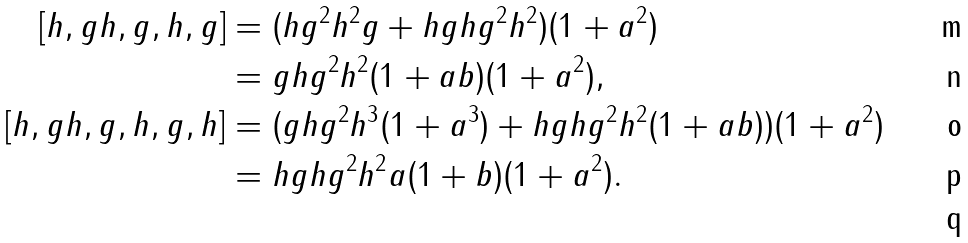Convert formula to latex. <formula><loc_0><loc_0><loc_500><loc_500>[ h , g h , g , h , g ] & = ( h g ^ { 2 } h ^ { 2 } g + h g h g ^ { 2 } h ^ { 2 } ) ( 1 + a ^ { 2 } ) \\ & = g h g ^ { 2 } h ^ { 2 } ( 1 + a b ) ( 1 + a ^ { 2 } ) , \\ [ h , g h , g , h , g , h ] & = ( g h g ^ { 2 } h ^ { 3 } ( 1 + a ^ { 3 } ) + h g h g ^ { 2 } h ^ { 2 } ( 1 + a b ) ) ( 1 + a ^ { 2 } ) \\ & = h g h g ^ { 2 } h ^ { 2 } a ( 1 + b ) ( 1 + a ^ { 2 } ) . \\</formula> 